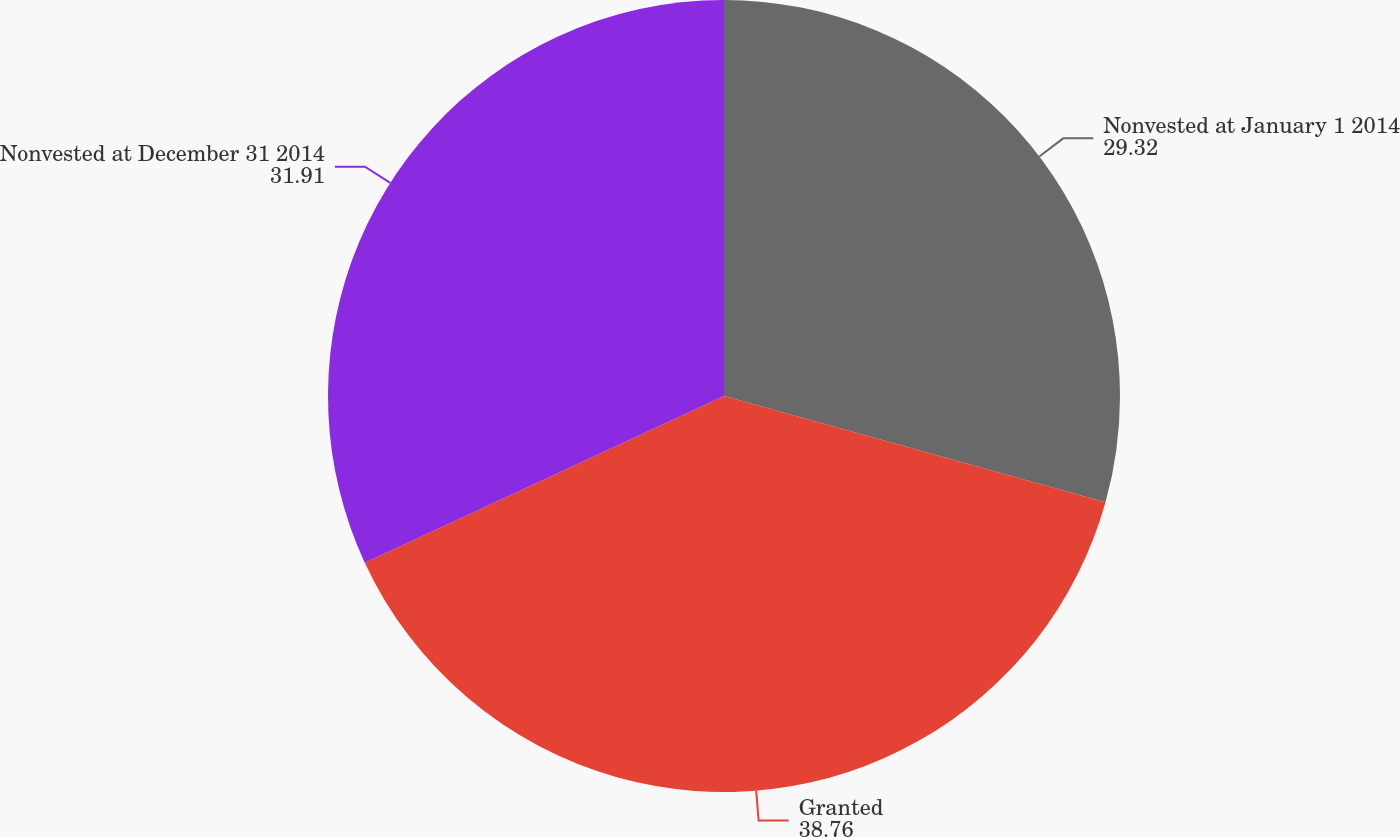Convert chart. <chart><loc_0><loc_0><loc_500><loc_500><pie_chart><fcel>Nonvested at January 1 2014<fcel>Granted<fcel>Nonvested at December 31 2014<nl><fcel>29.32%<fcel>38.76%<fcel>31.91%<nl></chart> 